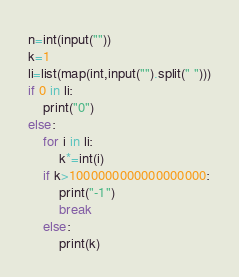<code> <loc_0><loc_0><loc_500><loc_500><_Python_>n=int(input(""))
k=1
li=list(map(int,input("").split(" ")))
if 0 in li:
    print("0")
else:
    for i in li:
        k*=int(i)
    if k>1000000000000000000:
        print("-1")
        break
    else:
        print(k)
</code> 